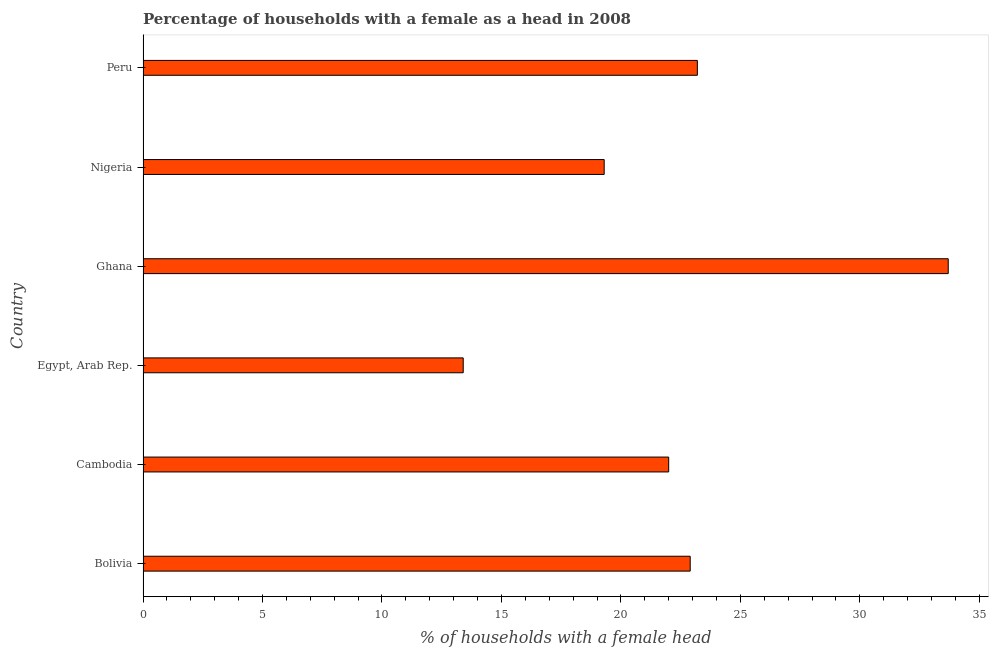Does the graph contain grids?
Keep it short and to the point. No. What is the title of the graph?
Provide a short and direct response. Percentage of households with a female as a head in 2008. What is the label or title of the X-axis?
Ensure brevity in your answer.  % of households with a female head. What is the number of female supervised households in Egypt, Arab Rep.?
Provide a succinct answer. 13.4. Across all countries, what is the maximum number of female supervised households?
Give a very brief answer. 33.7. Across all countries, what is the minimum number of female supervised households?
Provide a short and direct response. 13.4. In which country was the number of female supervised households maximum?
Ensure brevity in your answer.  Ghana. In which country was the number of female supervised households minimum?
Offer a terse response. Egypt, Arab Rep. What is the sum of the number of female supervised households?
Offer a very short reply. 134.5. What is the average number of female supervised households per country?
Keep it short and to the point. 22.42. What is the median number of female supervised households?
Your response must be concise. 22.45. In how many countries, is the number of female supervised households greater than 29 %?
Your response must be concise. 1. What is the ratio of the number of female supervised households in Cambodia to that in Ghana?
Give a very brief answer. 0.65. Is the number of female supervised households in Ghana less than that in Peru?
Provide a succinct answer. No. Is the difference between the number of female supervised households in Cambodia and Nigeria greater than the difference between any two countries?
Ensure brevity in your answer.  No. What is the difference between the highest and the second highest number of female supervised households?
Provide a succinct answer. 10.5. Is the sum of the number of female supervised households in Cambodia and Nigeria greater than the maximum number of female supervised households across all countries?
Ensure brevity in your answer.  Yes. What is the difference between the highest and the lowest number of female supervised households?
Offer a terse response. 20.3. In how many countries, is the number of female supervised households greater than the average number of female supervised households taken over all countries?
Give a very brief answer. 3. How many countries are there in the graph?
Your answer should be compact. 6. What is the difference between two consecutive major ticks on the X-axis?
Provide a short and direct response. 5. Are the values on the major ticks of X-axis written in scientific E-notation?
Give a very brief answer. No. What is the % of households with a female head in Bolivia?
Your answer should be compact. 22.9. What is the % of households with a female head in Ghana?
Provide a short and direct response. 33.7. What is the % of households with a female head in Nigeria?
Give a very brief answer. 19.3. What is the % of households with a female head in Peru?
Provide a succinct answer. 23.2. What is the difference between the % of households with a female head in Bolivia and Egypt, Arab Rep.?
Your answer should be compact. 9.5. What is the difference between the % of households with a female head in Bolivia and Peru?
Give a very brief answer. -0.3. What is the difference between the % of households with a female head in Cambodia and Egypt, Arab Rep.?
Provide a short and direct response. 8.6. What is the difference between the % of households with a female head in Cambodia and Ghana?
Ensure brevity in your answer.  -11.7. What is the difference between the % of households with a female head in Cambodia and Nigeria?
Your answer should be compact. 2.7. What is the difference between the % of households with a female head in Egypt, Arab Rep. and Ghana?
Your response must be concise. -20.3. What is the difference between the % of households with a female head in Egypt, Arab Rep. and Nigeria?
Your answer should be compact. -5.9. What is the difference between the % of households with a female head in Ghana and Peru?
Make the answer very short. 10.5. What is the ratio of the % of households with a female head in Bolivia to that in Cambodia?
Give a very brief answer. 1.04. What is the ratio of the % of households with a female head in Bolivia to that in Egypt, Arab Rep.?
Give a very brief answer. 1.71. What is the ratio of the % of households with a female head in Bolivia to that in Ghana?
Provide a short and direct response. 0.68. What is the ratio of the % of households with a female head in Bolivia to that in Nigeria?
Your answer should be very brief. 1.19. What is the ratio of the % of households with a female head in Cambodia to that in Egypt, Arab Rep.?
Your response must be concise. 1.64. What is the ratio of the % of households with a female head in Cambodia to that in Ghana?
Give a very brief answer. 0.65. What is the ratio of the % of households with a female head in Cambodia to that in Nigeria?
Keep it short and to the point. 1.14. What is the ratio of the % of households with a female head in Cambodia to that in Peru?
Provide a short and direct response. 0.95. What is the ratio of the % of households with a female head in Egypt, Arab Rep. to that in Ghana?
Offer a terse response. 0.4. What is the ratio of the % of households with a female head in Egypt, Arab Rep. to that in Nigeria?
Provide a succinct answer. 0.69. What is the ratio of the % of households with a female head in Egypt, Arab Rep. to that in Peru?
Your answer should be compact. 0.58. What is the ratio of the % of households with a female head in Ghana to that in Nigeria?
Your response must be concise. 1.75. What is the ratio of the % of households with a female head in Ghana to that in Peru?
Make the answer very short. 1.45. What is the ratio of the % of households with a female head in Nigeria to that in Peru?
Offer a terse response. 0.83. 